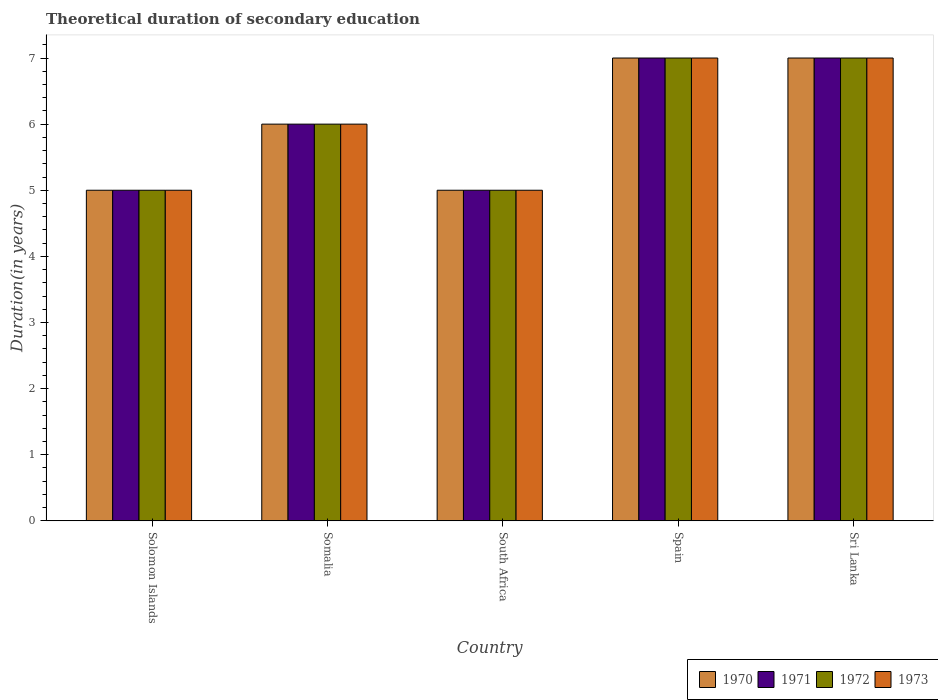Are the number of bars per tick equal to the number of legend labels?
Your answer should be very brief. Yes. How many bars are there on the 5th tick from the left?
Keep it short and to the point. 4. How many bars are there on the 4th tick from the right?
Offer a very short reply. 4. What is the label of the 3rd group of bars from the left?
Keep it short and to the point. South Africa. What is the total theoretical duration of secondary education in 1971 in Solomon Islands?
Ensure brevity in your answer.  5. Across all countries, what is the maximum total theoretical duration of secondary education in 1970?
Provide a succinct answer. 7. In which country was the total theoretical duration of secondary education in 1973 maximum?
Provide a short and direct response. Spain. In which country was the total theoretical duration of secondary education in 1973 minimum?
Your answer should be very brief. Solomon Islands. What is the difference between the total theoretical duration of secondary education in 1972 in Solomon Islands and that in Spain?
Your answer should be very brief. -2. What is the difference between the total theoretical duration of secondary education of/in 1973 and total theoretical duration of secondary education of/in 1972 in South Africa?
Your answer should be very brief. 0. In how many countries, is the total theoretical duration of secondary education in 1970 greater than 5 years?
Make the answer very short. 3. What is the ratio of the total theoretical duration of secondary education in 1971 in Solomon Islands to that in Spain?
Ensure brevity in your answer.  0.71. Is the total theoretical duration of secondary education in 1970 in Somalia less than that in Spain?
Ensure brevity in your answer.  Yes. What is the difference between the highest and the second highest total theoretical duration of secondary education in 1971?
Provide a short and direct response. -1. What is the difference between the highest and the lowest total theoretical duration of secondary education in 1971?
Offer a very short reply. 2. Is it the case that in every country, the sum of the total theoretical duration of secondary education in 1970 and total theoretical duration of secondary education in 1971 is greater than the sum of total theoretical duration of secondary education in 1973 and total theoretical duration of secondary education in 1972?
Your answer should be compact. No. What does the 3rd bar from the right in Solomon Islands represents?
Keep it short and to the point. 1971. Are all the bars in the graph horizontal?
Offer a very short reply. No. How many countries are there in the graph?
Give a very brief answer. 5. Does the graph contain grids?
Your answer should be very brief. No. Where does the legend appear in the graph?
Provide a short and direct response. Bottom right. How many legend labels are there?
Your answer should be compact. 4. What is the title of the graph?
Keep it short and to the point. Theoretical duration of secondary education. Does "1971" appear as one of the legend labels in the graph?
Give a very brief answer. Yes. What is the label or title of the X-axis?
Provide a succinct answer. Country. What is the label or title of the Y-axis?
Offer a very short reply. Duration(in years). What is the Duration(in years) of 1971 in Solomon Islands?
Your answer should be compact. 5. What is the Duration(in years) of 1972 in Solomon Islands?
Provide a succinct answer. 5. What is the Duration(in years) of 1970 in Somalia?
Your answer should be compact. 6. What is the Duration(in years) of 1973 in Somalia?
Ensure brevity in your answer.  6. What is the Duration(in years) of 1970 in South Africa?
Make the answer very short. 5. What is the Duration(in years) of 1971 in South Africa?
Make the answer very short. 5. What is the Duration(in years) of 1972 in South Africa?
Offer a very short reply. 5. What is the Duration(in years) in 1973 in South Africa?
Your answer should be very brief. 5. What is the Duration(in years) in 1972 in Spain?
Your answer should be very brief. 7. What is the Duration(in years) of 1970 in Sri Lanka?
Give a very brief answer. 7. Across all countries, what is the maximum Duration(in years) in 1973?
Offer a terse response. 7. Across all countries, what is the minimum Duration(in years) in 1970?
Your answer should be compact. 5. Across all countries, what is the minimum Duration(in years) in 1971?
Make the answer very short. 5. Across all countries, what is the minimum Duration(in years) of 1972?
Offer a terse response. 5. Across all countries, what is the minimum Duration(in years) of 1973?
Provide a short and direct response. 5. What is the total Duration(in years) of 1970 in the graph?
Your answer should be compact. 30. What is the difference between the Duration(in years) of 1970 in Solomon Islands and that in Somalia?
Provide a short and direct response. -1. What is the difference between the Duration(in years) of 1971 in Solomon Islands and that in Somalia?
Offer a terse response. -1. What is the difference between the Duration(in years) of 1970 in Solomon Islands and that in South Africa?
Keep it short and to the point. 0. What is the difference between the Duration(in years) in 1972 in Solomon Islands and that in South Africa?
Ensure brevity in your answer.  0. What is the difference between the Duration(in years) of 1970 in Solomon Islands and that in Spain?
Offer a very short reply. -2. What is the difference between the Duration(in years) in 1971 in Solomon Islands and that in Spain?
Make the answer very short. -2. What is the difference between the Duration(in years) of 1972 in Solomon Islands and that in Spain?
Give a very brief answer. -2. What is the difference between the Duration(in years) of 1973 in Solomon Islands and that in Spain?
Your answer should be very brief. -2. What is the difference between the Duration(in years) of 1972 in Solomon Islands and that in Sri Lanka?
Your response must be concise. -2. What is the difference between the Duration(in years) in 1973 in Solomon Islands and that in Sri Lanka?
Your answer should be compact. -2. What is the difference between the Duration(in years) in 1970 in Somalia and that in South Africa?
Provide a succinct answer. 1. What is the difference between the Duration(in years) of 1973 in Somalia and that in South Africa?
Your answer should be compact. 1. What is the difference between the Duration(in years) of 1970 in Somalia and that in Spain?
Provide a short and direct response. -1. What is the difference between the Duration(in years) of 1971 in Somalia and that in Spain?
Ensure brevity in your answer.  -1. What is the difference between the Duration(in years) in 1972 in Somalia and that in Spain?
Your answer should be compact. -1. What is the difference between the Duration(in years) of 1970 in Somalia and that in Sri Lanka?
Provide a succinct answer. -1. What is the difference between the Duration(in years) in 1972 in Somalia and that in Sri Lanka?
Provide a succinct answer. -1. What is the difference between the Duration(in years) in 1972 in South Africa and that in Spain?
Offer a very short reply. -2. What is the difference between the Duration(in years) of 1973 in South Africa and that in Spain?
Provide a short and direct response. -2. What is the difference between the Duration(in years) of 1970 in South Africa and that in Sri Lanka?
Ensure brevity in your answer.  -2. What is the difference between the Duration(in years) of 1971 in South Africa and that in Sri Lanka?
Provide a short and direct response. -2. What is the difference between the Duration(in years) in 1973 in South Africa and that in Sri Lanka?
Ensure brevity in your answer.  -2. What is the difference between the Duration(in years) in 1970 in Solomon Islands and the Duration(in years) in 1971 in Somalia?
Provide a short and direct response. -1. What is the difference between the Duration(in years) in 1970 in Solomon Islands and the Duration(in years) in 1972 in Somalia?
Give a very brief answer. -1. What is the difference between the Duration(in years) in 1971 in Solomon Islands and the Duration(in years) in 1973 in Somalia?
Make the answer very short. -1. What is the difference between the Duration(in years) in 1970 in Solomon Islands and the Duration(in years) in 1971 in South Africa?
Provide a succinct answer. 0. What is the difference between the Duration(in years) of 1970 in Solomon Islands and the Duration(in years) of 1973 in South Africa?
Provide a short and direct response. 0. What is the difference between the Duration(in years) of 1971 in Solomon Islands and the Duration(in years) of 1972 in South Africa?
Your answer should be compact. 0. What is the difference between the Duration(in years) of 1971 in Solomon Islands and the Duration(in years) of 1973 in South Africa?
Give a very brief answer. 0. What is the difference between the Duration(in years) of 1972 in Solomon Islands and the Duration(in years) of 1973 in South Africa?
Offer a very short reply. 0. What is the difference between the Duration(in years) of 1970 in Solomon Islands and the Duration(in years) of 1971 in Spain?
Provide a succinct answer. -2. What is the difference between the Duration(in years) of 1970 in Solomon Islands and the Duration(in years) of 1972 in Spain?
Make the answer very short. -2. What is the difference between the Duration(in years) in 1970 in Solomon Islands and the Duration(in years) in 1973 in Spain?
Offer a terse response. -2. What is the difference between the Duration(in years) in 1971 in Solomon Islands and the Duration(in years) in 1972 in Spain?
Keep it short and to the point. -2. What is the difference between the Duration(in years) in 1971 in Solomon Islands and the Duration(in years) in 1973 in Spain?
Offer a very short reply. -2. What is the difference between the Duration(in years) of 1972 in Solomon Islands and the Duration(in years) of 1973 in Spain?
Provide a succinct answer. -2. What is the difference between the Duration(in years) of 1970 in Solomon Islands and the Duration(in years) of 1972 in Sri Lanka?
Provide a succinct answer. -2. What is the difference between the Duration(in years) in 1971 in Solomon Islands and the Duration(in years) in 1972 in Sri Lanka?
Your response must be concise. -2. What is the difference between the Duration(in years) in 1971 in Solomon Islands and the Duration(in years) in 1973 in Sri Lanka?
Give a very brief answer. -2. What is the difference between the Duration(in years) in 1972 in Solomon Islands and the Duration(in years) in 1973 in Sri Lanka?
Give a very brief answer. -2. What is the difference between the Duration(in years) of 1971 in Somalia and the Duration(in years) of 1972 in South Africa?
Provide a short and direct response. 1. What is the difference between the Duration(in years) of 1970 in Somalia and the Duration(in years) of 1972 in Spain?
Make the answer very short. -1. What is the difference between the Duration(in years) in 1972 in Somalia and the Duration(in years) in 1973 in Spain?
Make the answer very short. -1. What is the difference between the Duration(in years) of 1970 in Somalia and the Duration(in years) of 1972 in Sri Lanka?
Offer a very short reply. -1. What is the difference between the Duration(in years) of 1970 in Somalia and the Duration(in years) of 1973 in Sri Lanka?
Provide a succinct answer. -1. What is the difference between the Duration(in years) in 1970 in South Africa and the Duration(in years) in 1971 in Spain?
Offer a very short reply. -2. What is the difference between the Duration(in years) in 1970 in South Africa and the Duration(in years) in 1971 in Sri Lanka?
Offer a terse response. -2. What is the difference between the Duration(in years) of 1970 in South Africa and the Duration(in years) of 1972 in Sri Lanka?
Make the answer very short. -2. What is the difference between the Duration(in years) of 1970 in South Africa and the Duration(in years) of 1973 in Sri Lanka?
Offer a very short reply. -2. What is the difference between the Duration(in years) of 1971 in South Africa and the Duration(in years) of 1972 in Sri Lanka?
Offer a very short reply. -2. What is the difference between the Duration(in years) in 1971 in South Africa and the Duration(in years) in 1973 in Sri Lanka?
Your answer should be very brief. -2. What is the difference between the Duration(in years) in 1970 in Spain and the Duration(in years) in 1971 in Sri Lanka?
Keep it short and to the point. 0. What is the difference between the Duration(in years) of 1970 in Spain and the Duration(in years) of 1972 in Sri Lanka?
Keep it short and to the point. 0. What is the difference between the Duration(in years) in 1970 in Spain and the Duration(in years) in 1973 in Sri Lanka?
Provide a short and direct response. 0. What is the difference between the Duration(in years) of 1971 in Spain and the Duration(in years) of 1972 in Sri Lanka?
Provide a short and direct response. 0. What is the difference between the Duration(in years) of 1972 in Spain and the Duration(in years) of 1973 in Sri Lanka?
Give a very brief answer. 0. What is the average Duration(in years) in 1972 per country?
Keep it short and to the point. 6. What is the average Duration(in years) in 1973 per country?
Give a very brief answer. 6. What is the difference between the Duration(in years) of 1970 and Duration(in years) of 1973 in Solomon Islands?
Your answer should be compact. 0. What is the difference between the Duration(in years) of 1971 and Duration(in years) of 1973 in Solomon Islands?
Provide a succinct answer. 0. What is the difference between the Duration(in years) in 1972 and Duration(in years) in 1973 in Solomon Islands?
Your answer should be very brief. 0. What is the difference between the Duration(in years) of 1970 and Duration(in years) of 1973 in Somalia?
Give a very brief answer. 0. What is the difference between the Duration(in years) of 1971 and Duration(in years) of 1973 in Somalia?
Provide a succinct answer. 0. What is the difference between the Duration(in years) of 1972 and Duration(in years) of 1973 in Somalia?
Give a very brief answer. 0. What is the difference between the Duration(in years) of 1970 and Duration(in years) of 1971 in South Africa?
Your response must be concise. 0. What is the difference between the Duration(in years) in 1970 and Duration(in years) in 1973 in South Africa?
Provide a short and direct response. 0. What is the difference between the Duration(in years) in 1971 and Duration(in years) in 1972 in South Africa?
Provide a succinct answer. 0. What is the difference between the Duration(in years) of 1970 and Duration(in years) of 1972 in Spain?
Offer a very short reply. 0. What is the difference between the Duration(in years) of 1971 and Duration(in years) of 1972 in Spain?
Give a very brief answer. 0. What is the difference between the Duration(in years) in 1972 and Duration(in years) in 1973 in Spain?
Make the answer very short. 0. What is the difference between the Duration(in years) of 1970 and Duration(in years) of 1971 in Sri Lanka?
Your answer should be compact. 0. What is the difference between the Duration(in years) of 1970 and Duration(in years) of 1973 in Sri Lanka?
Your response must be concise. 0. What is the difference between the Duration(in years) of 1971 and Duration(in years) of 1972 in Sri Lanka?
Make the answer very short. 0. What is the difference between the Duration(in years) in 1971 and Duration(in years) in 1973 in Sri Lanka?
Keep it short and to the point. 0. What is the ratio of the Duration(in years) of 1972 in Solomon Islands to that in Somalia?
Your response must be concise. 0.83. What is the ratio of the Duration(in years) of 1973 in Solomon Islands to that in Somalia?
Provide a short and direct response. 0.83. What is the ratio of the Duration(in years) of 1970 in Solomon Islands to that in South Africa?
Offer a terse response. 1. What is the ratio of the Duration(in years) of 1972 in Solomon Islands to that in South Africa?
Provide a succinct answer. 1. What is the ratio of the Duration(in years) of 1970 in Solomon Islands to that in Spain?
Make the answer very short. 0.71. What is the ratio of the Duration(in years) of 1971 in Solomon Islands to that in Spain?
Offer a very short reply. 0.71. What is the ratio of the Duration(in years) in 1972 in Solomon Islands to that in Spain?
Your answer should be compact. 0.71. What is the ratio of the Duration(in years) of 1973 in Solomon Islands to that in Spain?
Provide a succinct answer. 0.71. What is the ratio of the Duration(in years) in 1970 in Solomon Islands to that in Sri Lanka?
Provide a succinct answer. 0.71. What is the ratio of the Duration(in years) of 1971 in Solomon Islands to that in Sri Lanka?
Keep it short and to the point. 0.71. What is the ratio of the Duration(in years) in 1972 in Solomon Islands to that in Sri Lanka?
Give a very brief answer. 0.71. What is the ratio of the Duration(in years) of 1973 in Solomon Islands to that in Sri Lanka?
Offer a terse response. 0.71. What is the ratio of the Duration(in years) in 1972 in Somalia to that in South Africa?
Your answer should be compact. 1.2. What is the ratio of the Duration(in years) of 1970 in Somalia to that in Spain?
Make the answer very short. 0.86. What is the ratio of the Duration(in years) in 1972 in Somalia to that in Sri Lanka?
Your response must be concise. 0.86. What is the ratio of the Duration(in years) of 1971 in South Africa to that in Spain?
Give a very brief answer. 0.71. What is the ratio of the Duration(in years) of 1972 in South Africa to that in Spain?
Offer a terse response. 0.71. What is the ratio of the Duration(in years) of 1973 in South Africa to that in Spain?
Provide a short and direct response. 0.71. What is the ratio of the Duration(in years) in 1970 in Spain to that in Sri Lanka?
Offer a terse response. 1. What is the ratio of the Duration(in years) in 1971 in Spain to that in Sri Lanka?
Your response must be concise. 1. What is the difference between the highest and the second highest Duration(in years) in 1970?
Make the answer very short. 0. What is the difference between the highest and the second highest Duration(in years) in 1971?
Give a very brief answer. 0. What is the difference between the highest and the second highest Duration(in years) in 1973?
Keep it short and to the point. 0. What is the difference between the highest and the lowest Duration(in years) in 1970?
Your answer should be compact. 2. 